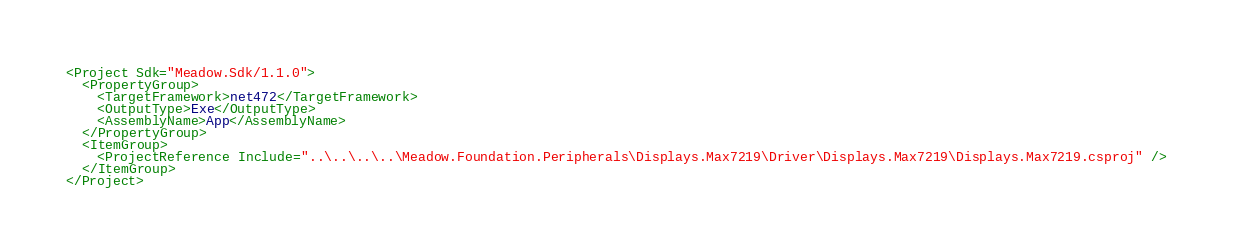<code> <loc_0><loc_0><loc_500><loc_500><_XML_><Project Sdk="Meadow.Sdk/1.1.0">
  <PropertyGroup>
    <TargetFramework>net472</TargetFramework>
    <OutputType>Exe</OutputType>
    <AssemblyName>App</AssemblyName>
  </PropertyGroup>
  <ItemGroup>
    <ProjectReference Include="..\..\..\..\Meadow.Foundation.Peripherals\Displays.Max7219\Driver\Displays.Max7219\Displays.Max7219.csproj" />
  </ItemGroup>
</Project>
</code> 